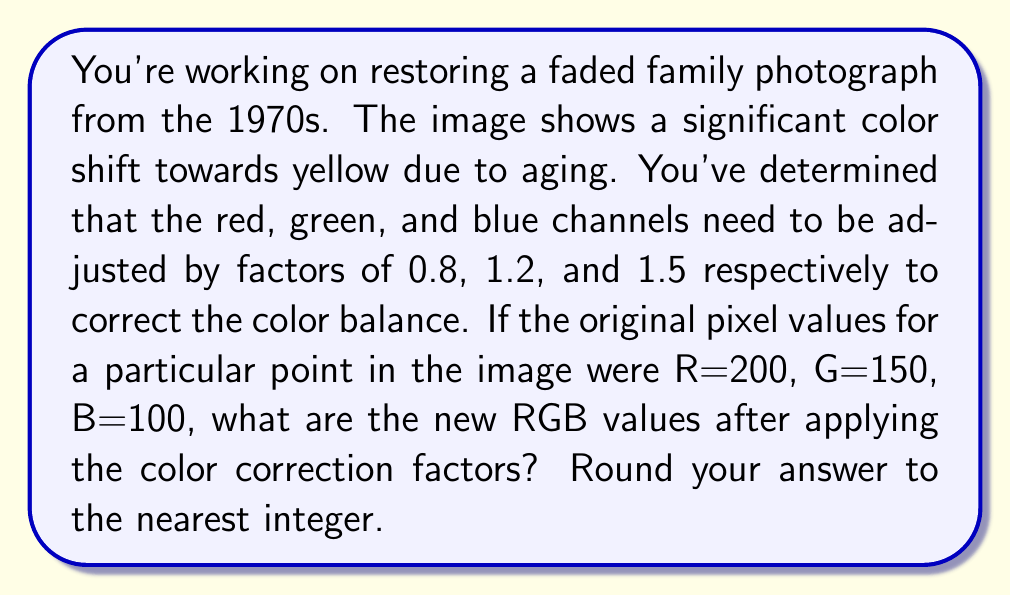Can you answer this question? To solve this problem, we need to follow these steps:

1. Understand the given information:
   - Original RGB values: R=200, G=150, B=100
   - Correction factors: Red: 0.8, Green: 1.2, Blue: 1.5

2. Apply the correction factors to each color channel:

   For Red:
   $$R_{new} = R_{original} \times \text{correction factor}$$
   $$R_{new} = 200 \times 0.8 = 160$$

   For Green:
   $$G_{new} = G_{original} \times \text{correction factor}$$
   $$G_{new} = 150 \times 1.2 = 180$$

   For Blue:
   $$B_{new} = B_{original} \times \text{correction factor}$$
   $$B_{new} = 100 \times 1.5 = 150$$

3. Round the results to the nearest integer:
   R = 160 (already an integer)
   G = 180 (already an integer)
   B = 150 (already an integer)

4. Present the final RGB values in the format (R, G, B).
Answer: (160, 180, 150) 